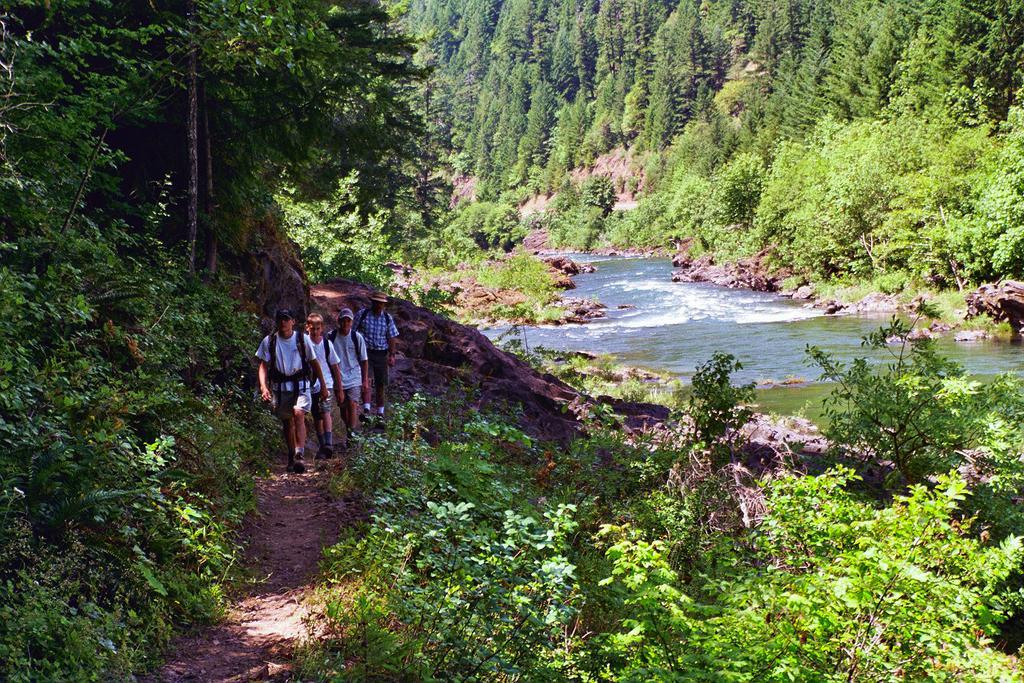In one or two sentences, can you explain what this image depicts? This picture is clicked outside the city. In the foreground we can see the plants. In the center we can see the group of people walking on the ground and there is a water body. In the background we can see the trees and the rocks. 